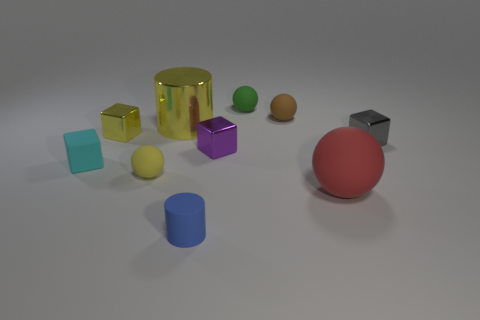Subtract all small green balls. How many balls are left? 3 Subtract all yellow balls. How many balls are left? 3 Subtract 1 spheres. How many spheres are left? 3 Add 8 matte cylinders. How many matte cylinders are left? 9 Add 2 big brown objects. How many big brown objects exist? 2 Subtract 0 blue balls. How many objects are left? 10 Subtract all spheres. How many objects are left? 6 Subtract all green balls. Subtract all red blocks. How many balls are left? 3 Subtract all yellow spheres. How many gray cylinders are left? 0 Subtract all purple things. Subtract all small brown things. How many objects are left? 8 